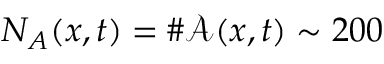<formula> <loc_0><loc_0><loc_500><loc_500>N _ { A } ( x , t ) = \# \mathcal { A } ( x , t ) \sim 2 0 0</formula> 